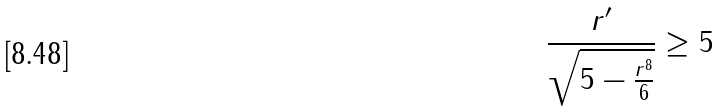Convert formula to latex. <formula><loc_0><loc_0><loc_500><loc_500>\frac { r ^ { \prime } } { \sqrt { 5 - \frac { r ^ { 8 } } { 6 } } } \geq 5</formula> 